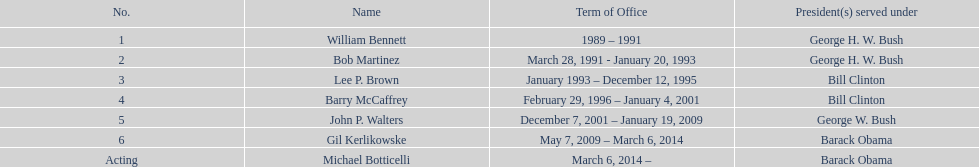How long did bob martinez serve as director? 2 years. 